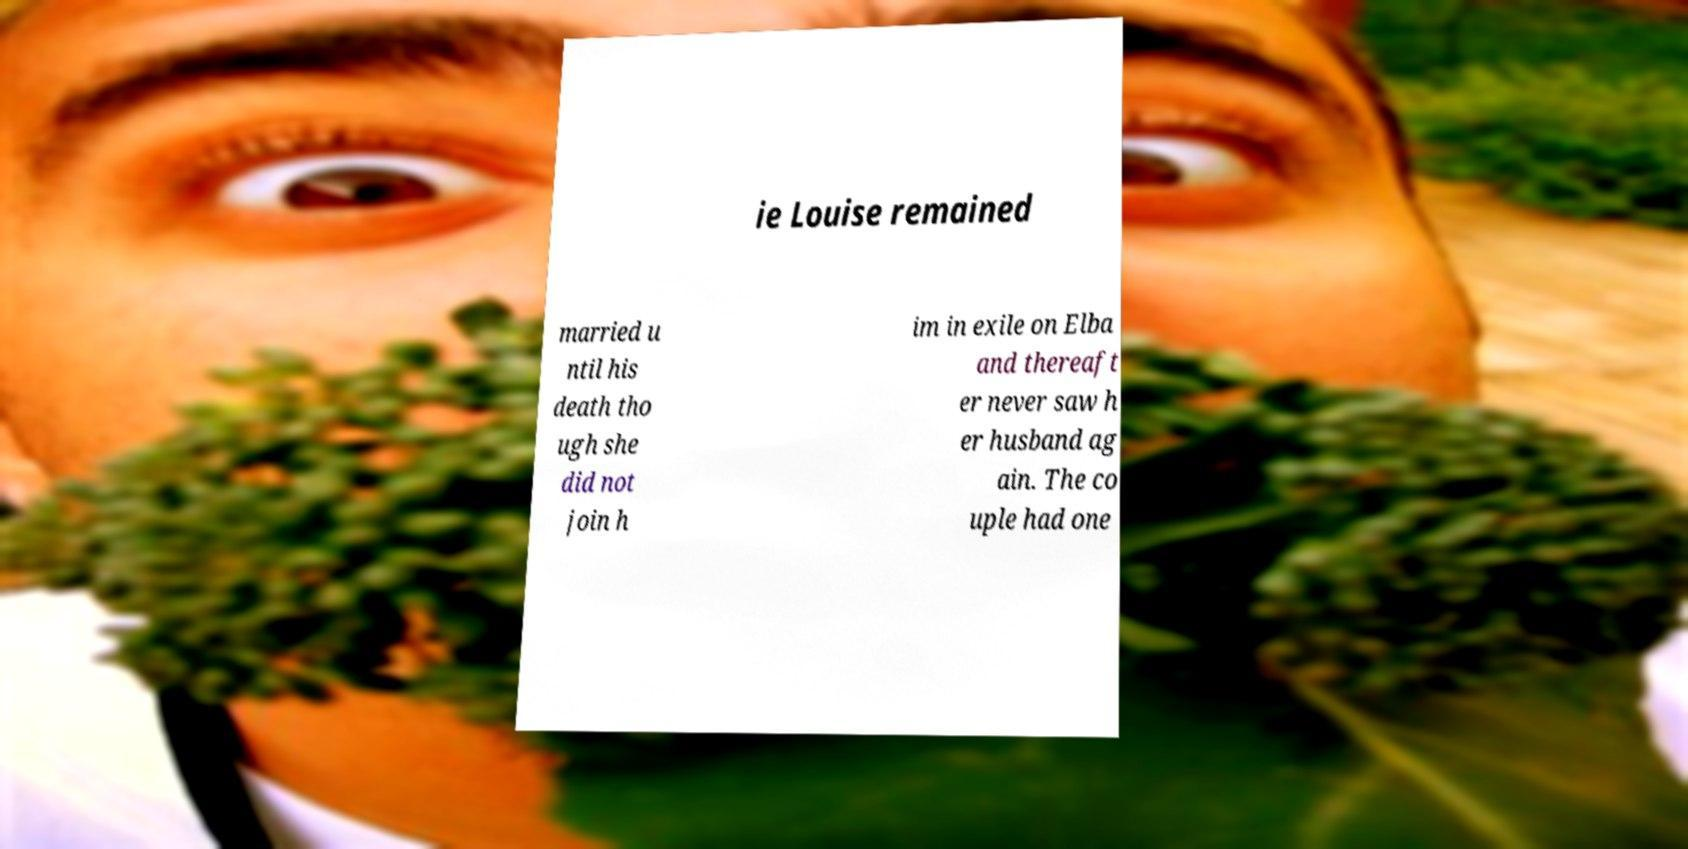Can you accurately transcribe the text from the provided image for me? ie Louise remained married u ntil his death tho ugh she did not join h im in exile on Elba and thereaft er never saw h er husband ag ain. The co uple had one 